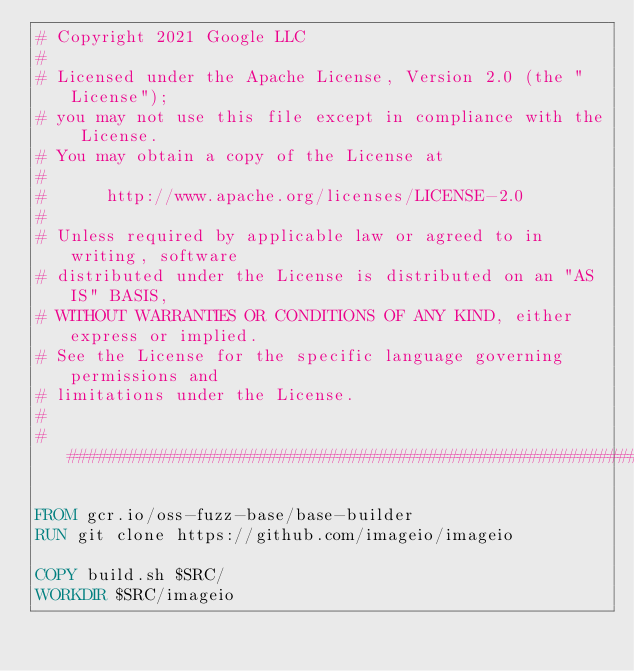Convert code to text. <code><loc_0><loc_0><loc_500><loc_500><_Dockerfile_># Copyright 2021 Google LLC
#
# Licensed under the Apache License, Version 2.0 (the "License");
# you may not use this file except in compliance with the License.
# You may obtain a copy of the License at
#
#      http://www.apache.org/licenses/LICENSE-2.0
#
# Unless required by applicable law or agreed to in writing, software
# distributed under the License is distributed on an "AS IS" BASIS,
# WITHOUT WARRANTIES OR CONDITIONS OF ANY KIND, either express or implied.
# See the License for the specific language governing permissions and
# limitations under the License.
#
################################################################################

FROM gcr.io/oss-fuzz-base/base-builder
RUN git clone https://github.com/imageio/imageio

COPY build.sh $SRC/
WORKDIR $SRC/imageio
</code> 